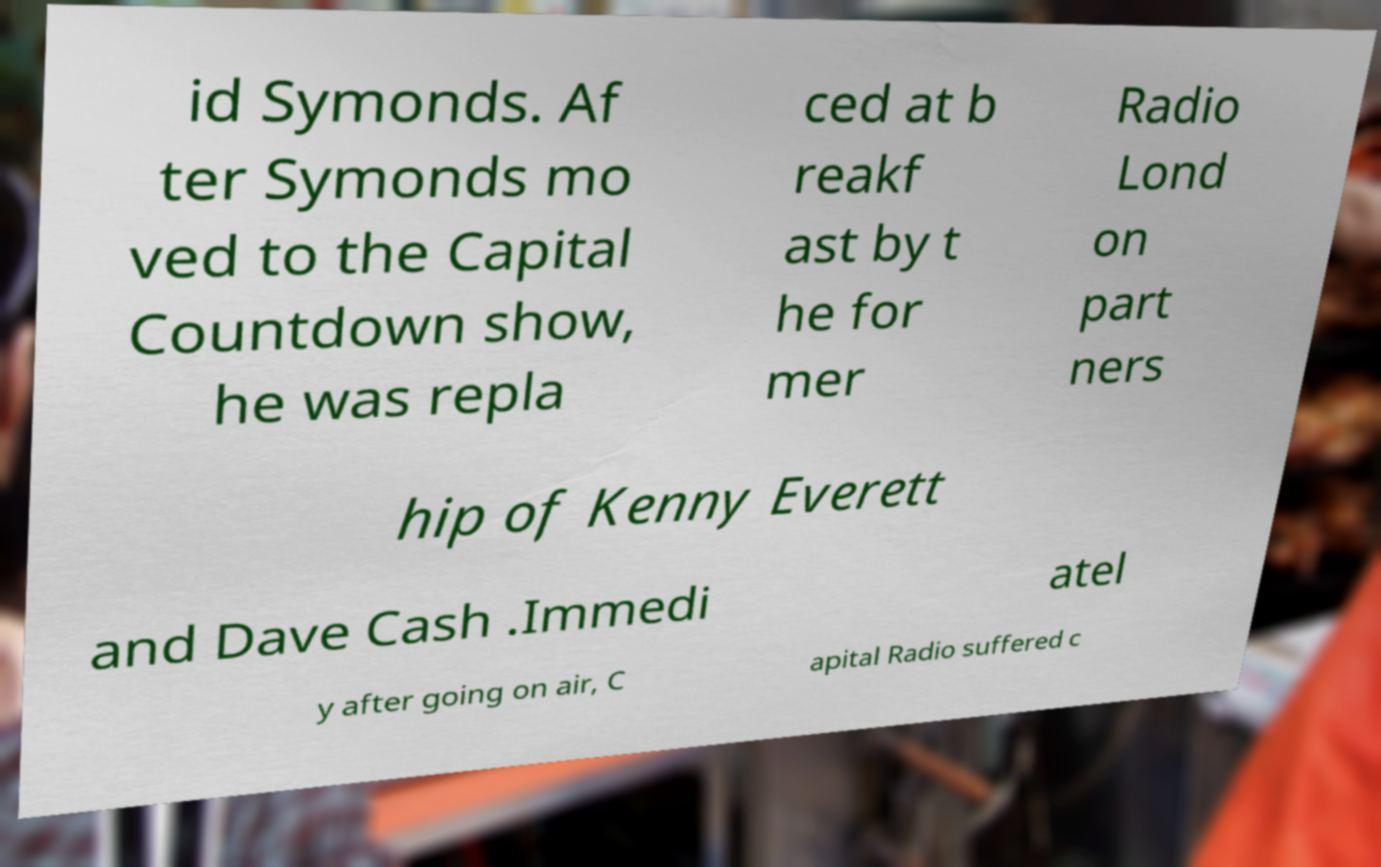Could you extract and type out the text from this image? id Symonds. Af ter Symonds mo ved to the Capital Countdown show, he was repla ced at b reakf ast by t he for mer Radio Lond on part ners hip of Kenny Everett and Dave Cash .Immedi atel y after going on air, C apital Radio suffered c 